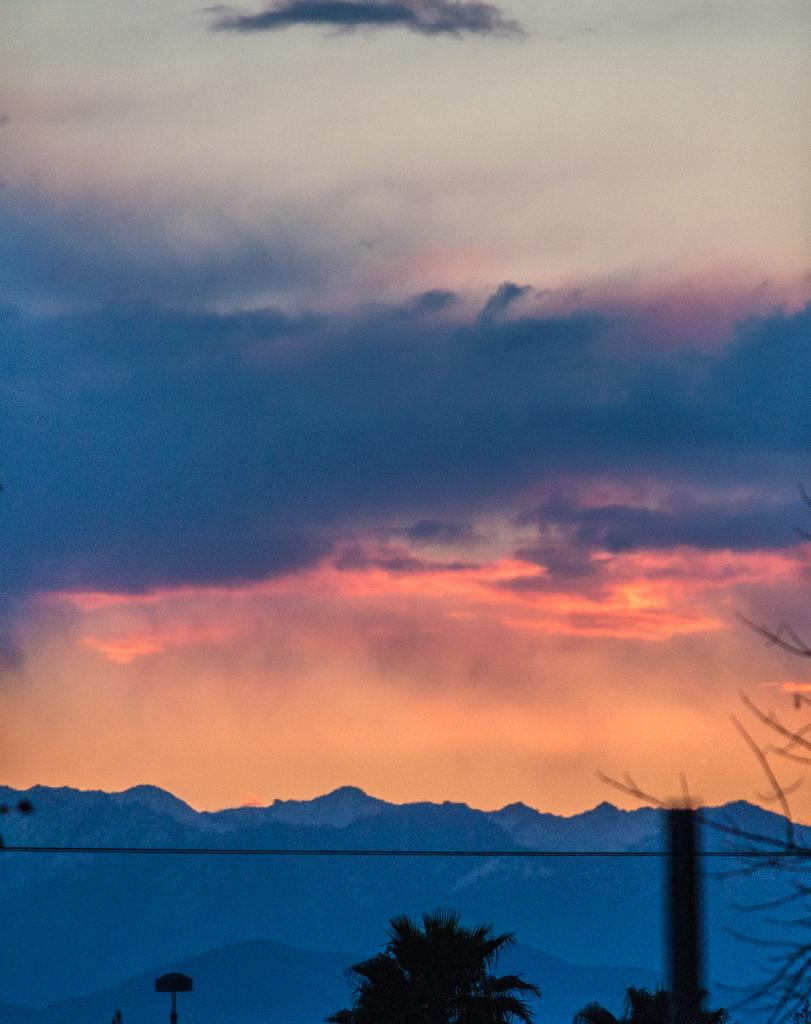What can be seen in the sky in the image? The sky with clouds is visible in the image. What type of natural landscape is present in the image? There are hills in the image. What is the man-made object in the image? There is a cable in the image. What type of vegetation is present in the image? Trees are present in the image. What type of authority is depicted in the image? There is no authority figure present in the image. Where are the dolls located in the image? There are no dolls present in the image. What type of hall is visible in the image? There is no hall present in the image. 